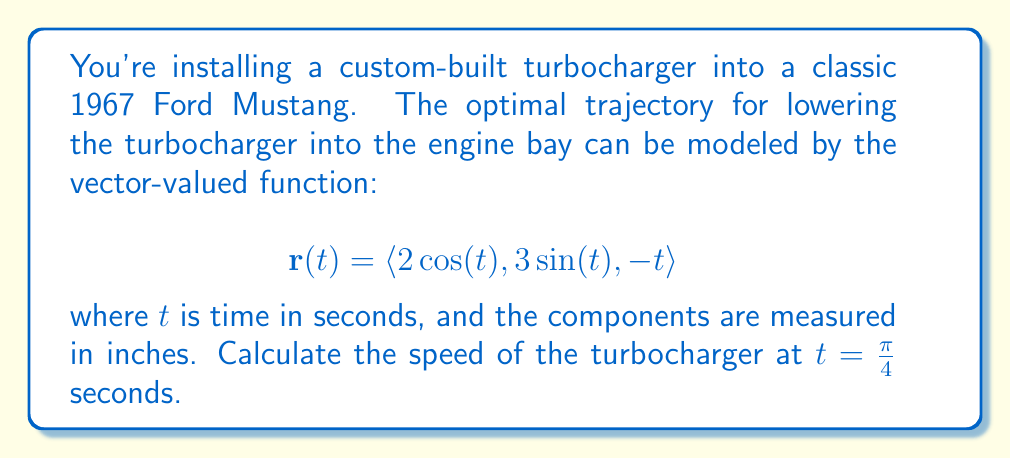Show me your answer to this math problem. To solve this problem, we need to follow these steps:

1) The speed of an object following a path described by a vector-valued function is given by the magnitude of the velocity vector. The velocity vector is the derivative of the position vector with respect to time.

2) Let's first find the velocity vector by differentiating $\mathbf{r}(t)$ with respect to $t$:

   $$\mathbf{r}'(t) = \langle -2\sin(t), 3\cos(t), -1 \rangle$$

3) The speed is the magnitude of this velocity vector. We can calculate it using the formula:

   $$\text{speed} = \|\mathbf{r}'(t)\| = \sqrt{(-2\sin(t))^2 + (3\cos(t))^2 + (-1)^2}$$

4) Now, we need to evaluate this at $t = \frac{\pi}{4}$:

   $$\text{speed} = \sqrt{(-2\sin(\frac{\pi}{4}))^2 + (3\cos(\frac{\pi}{4}))^2 + (-1)^2}$$

5) Recall that $\sin(\frac{\pi}{4}) = \cos(\frac{\pi}{4}) = \frac{\sqrt{2}}{2}$:

   $$\text{speed} = \sqrt{(-2\cdot\frac{\sqrt{2}}{2})^2 + (3\cdot\frac{\sqrt{2}}{2})^2 + (-1)^2}$$

6) Simplify:

   $$\text{speed} = \sqrt{2^2 + (\frac{3\sqrt{2}}{2})^2 + 1^2} = \sqrt{4 + \frac{18}{4} + 1} = \sqrt{\frac{25}{4}} = \frac{5}{2}$$

Therefore, the speed of the turbocharger at $t = \frac{\pi}{4}$ seconds is $\frac{5}{2}$ inches per second.
Answer: $\frac{5}{2}$ inches per second 